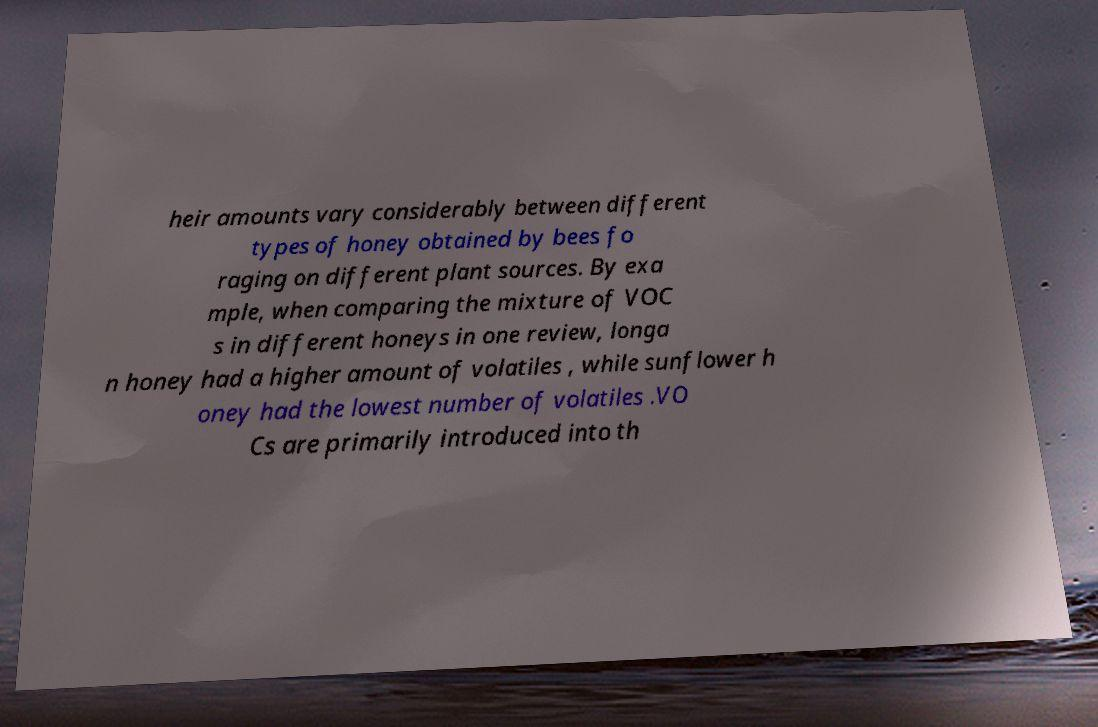I need the written content from this picture converted into text. Can you do that? heir amounts vary considerably between different types of honey obtained by bees fo raging on different plant sources. By exa mple, when comparing the mixture of VOC s in different honeys in one review, longa n honey had a higher amount of volatiles , while sunflower h oney had the lowest number of volatiles .VO Cs are primarily introduced into th 